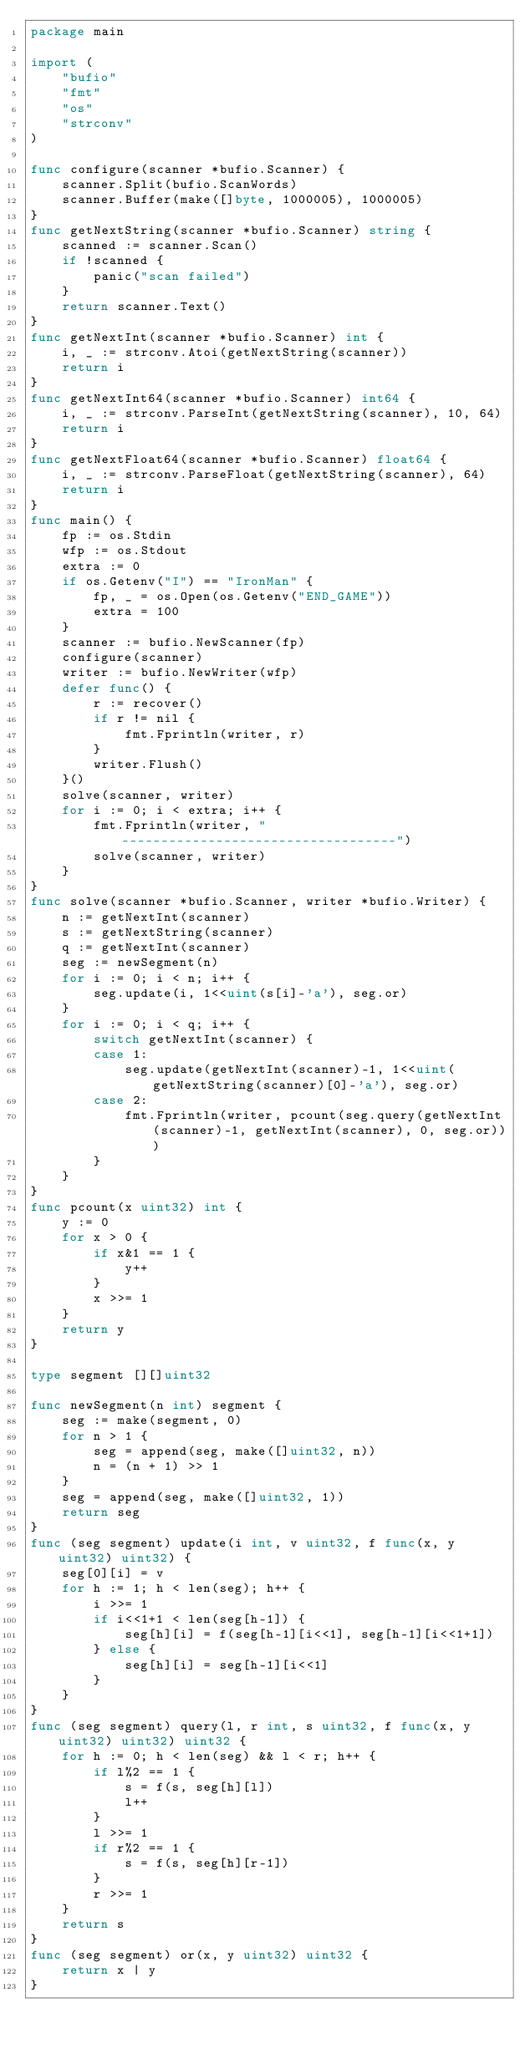Convert code to text. <code><loc_0><loc_0><loc_500><loc_500><_Go_>package main

import (
	"bufio"
	"fmt"
	"os"
	"strconv"
)

func configure(scanner *bufio.Scanner) {
	scanner.Split(bufio.ScanWords)
	scanner.Buffer(make([]byte, 1000005), 1000005)
}
func getNextString(scanner *bufio.Scanner) string {
	scanned := scanner.Scan()
	if !scanned {
		panic("scan failed")
	}
	return scanner.Text()
}
func getNextInt(scanner *bufio.Scanner) int {
	i, _ := strconv.Atoi(getNextString(scanner))
	return i
}
func getNextInt64(scanner *bufio.Scanner) int64 {
	i, _ := strconv.ParseInt(getNextString(scanner), 10, 64)
	return i
}
func getNextFloat64(scanner *bufio.Scanner) float64 {
	i, _ := strconv.ParseFloat(getNextString(scanner), 64)
	return i
}
func main() {
	fp := os.Stdin
	wfp := os.Stdout
	extra := 0
	if os.Getenv("I") == "IronMan" {
		fp, _ = os.Open(os.Getenv("END_GAME"))
		extra = 100
	}
	scanner := bufio.NewScanner(fp)
	configure(scanner)
	writer := bufio.NewWriter(wfp)
	defer func() {
		r := recover()
		if r != nil {
			fmt.Fprintln(writer, r)
		}
		writer.Flush()
	}()
	solve(scanner, writer)
	for i := 0; i < extra; i++ {
		fmt.Fprintln(writer, "-----------------------------------")
		solve(scanner, writer)
	}
}
func solve(scanner *bufio.Scanner, writer *bufio.Writer) {
	n := getNextInt(scanner)
	s := getNextString(scanner)
	q := getNextInt(scanner)
	seg := newSegment(n)
	for i := 0; i < n; i++ {
		seg.update(i, 1<<uint(s[i]-'a'), seg.or)
	}
	for i := 0; i < q; i++ {
		switch getNextInt(scanner) {
		case 1:
			seg.update(getNextInt(scanner)-1, 1<<uint(getNextString(scanner)[0]-'a'), seg.or)
		case 2:
			fmt.Fprintln(writer, pcount(seg.query(getNextInt(scanner)-1, getNextInt(scanner), 0, seg.or)))
		}
	}
}
func pcount(x uint32) int {
	y := 0
	for x > 0 {
		if x&1 == 1 {
			y++
		}
		x >>= 1
	}
	return y
}

type segment [][]uint32

func newSegment(n int) segment {
	seg := make(segment, 0)
	for n > 1 {
		seg = append(seg, make([]uint32, n))
		n = (n + 1) >> 1
	}
	seg = append(seg, make([]uint32, 1))
	return seg
}
func (seg segment) update(i int, v uint32, f func(x, y uint32) uint32) {
	seg[0][i] = v
	for h := 1; h < len(seg); h++ {
		i >>= 1
		if i<<1+1 < len(seg[h-1]) {
			seg[h][i] = f(seg[h-1][i<<1], seg[h-1][i<<1+1])
		} else {
			seg[h][i] = seg[h-1][i<<1]
		}
	}
}
func (seg segment) query(l, r int, s uint32, f func(x, y uint32) uint32) uint32 {
	for h := 0; h < len(seg) && l < r; h++ {
		if l%2 == 1 {
			s = f(s, seg[h][l])
			l++
		}
		l >>= 1
		if r%2 == 1 {
			s = f(s, seg[h][r-1])
		}
		r >>= 1
	}
	return s
}
func (seg segment) or(x, y uint32) uint32 {
	return x | y
}
</code> 